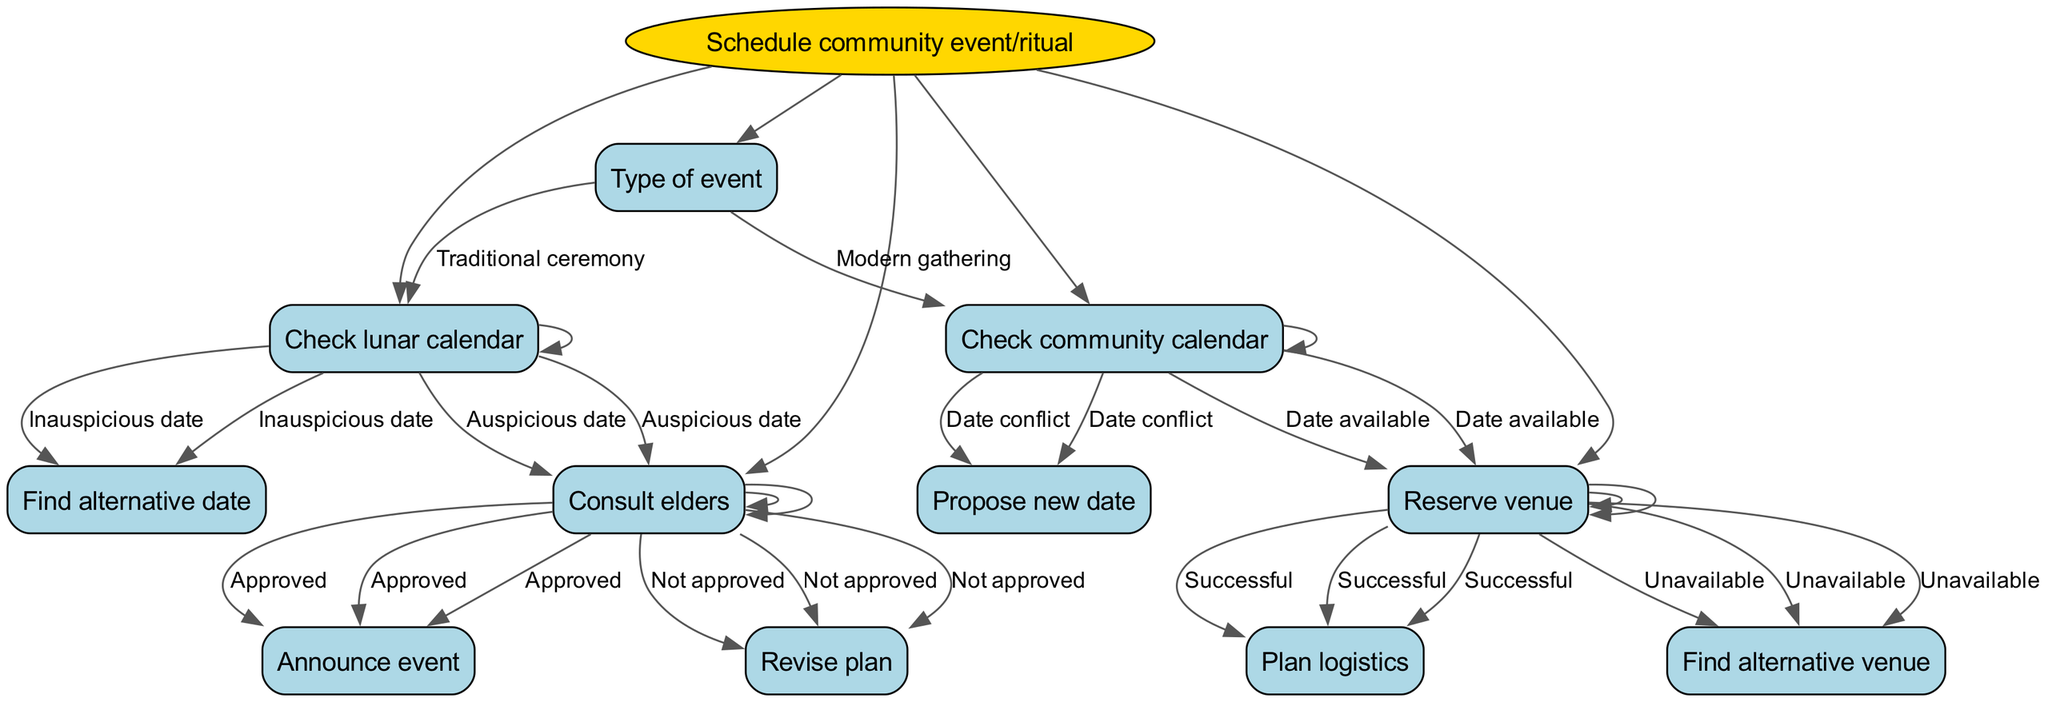What is the root node of the decision tree? The root node is the starting point of the decision tree, which represents the main topic or decision being discussed. In this case, the root node explicitly states "Schedule community event/ritual."
Answer: Schedule community event/ritual How many main decision nodes are there in the diagram? The diagram presents several main decision nodes that lead to various options. Counting them, we find there are five main decision nodes branching from the initial decision.
Answer: 5 What happens if the date is inauspicious after checking the lunar calendar? According to the diagram, if the date is deemed inauspicious when checking the lunar calendar, the next action is to "Find alternative date." This represents the follow-up decision to change the planned date.
Answer: Find alternative date What is the next step after reserving the venue successfully? Based on the flow of the diagram, if the venue reservation is successful, the following step is to "Plan logistics." This indicates the continuation of planning for the event after securing a location.
Answer: Plan logistics What decision follows if there is a date conflict on the community calendar? The decision tree states that if there is a date conflict on the community calendar, it prompts the next action to "Propose new date." This suggests that the planning process will consider an alternative date for the event.
Answer: Propose new date Which decision leads to the consultation of elders? Within the diagram, the decision to consult elders only occurs after confirming an auspicious date on the lunar calendar. This connection illustrates a clear pathway that begins with checking the lunar calendar and leads to this consultation.
Answer: Consult elders 